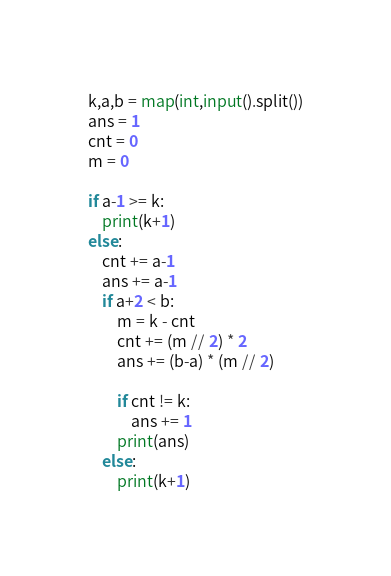Convert code to text. <code><loc_0><loc_0><loc_500><loc_500><_Python_>k,a,b = map(int,input().split())
ans = 1
cnt = 0
m = 0

if a-1 >= k:
    print(k+1)
else:
    cnt += a-1
    ans += a-1
    if a+2 < b:
        m = k - cnt
        cnt += (m // 2) * 2
        ans += (b-a) * (m // 2)

        if cnt != k:
            ans += 1
        print(ans)
    else:
        print(k+1)
</code> 